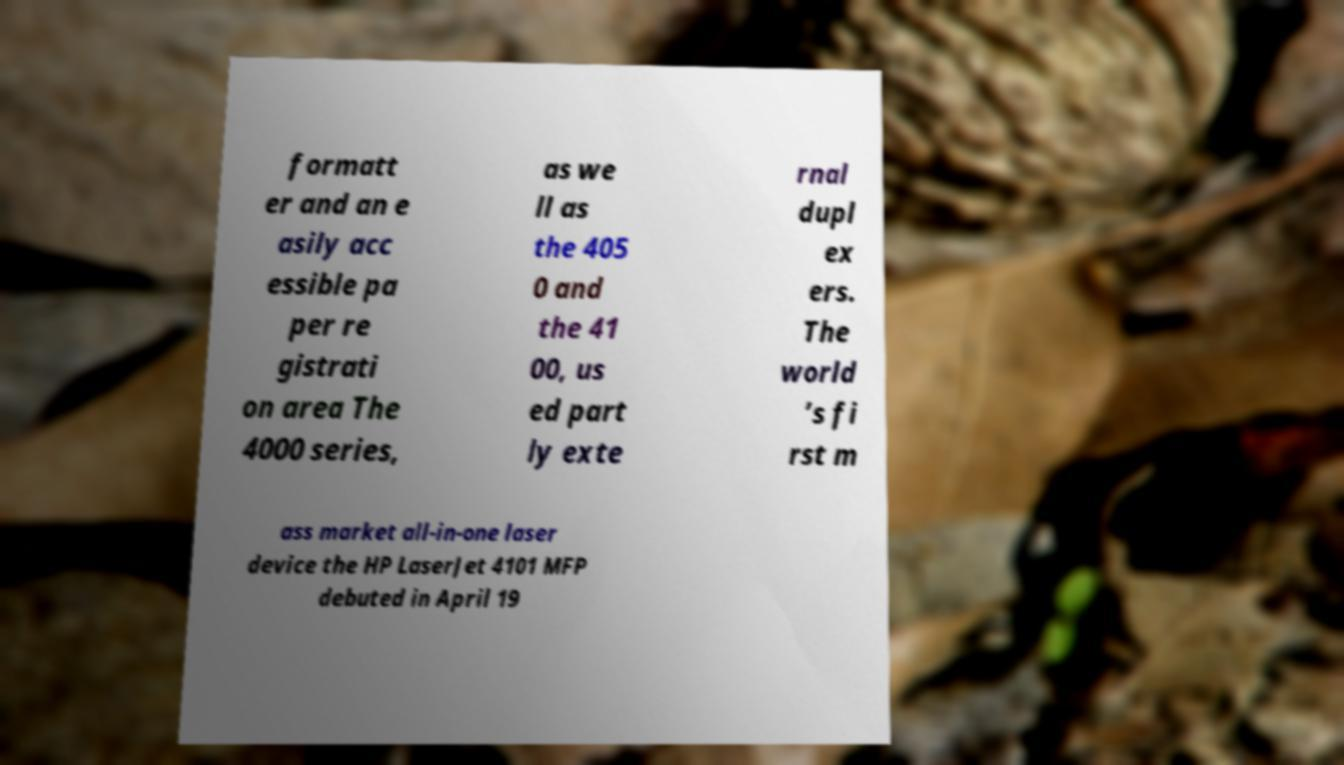Can you accurately transcribe the text from the provided image for me? formatt er and an e asily acc essible pa per re gistrati on area The 4000 series, as we ll as the 405 0 and the 41 00, us ed part ly exte rnal dupl ex ers. The world ’s fi rst m ass market all-in-one laser device the HP LaserJet 4101 MFP debuted in April 19 